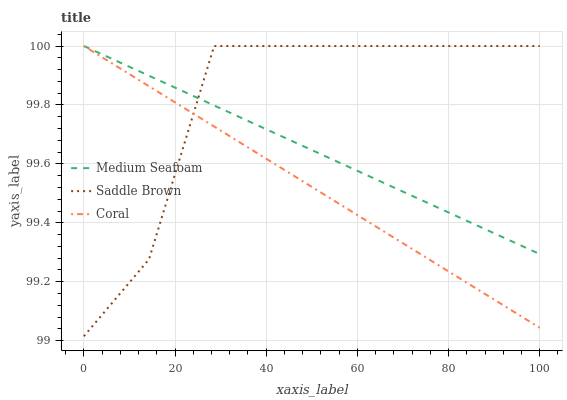Does Coral have the minimum area under the curve?
Answer yes or no. Yes. Does Saddle Brown have the maximum area under the curve?
Answer yes or no. Yes. Does Medium Seafoam have the minimum area under the curve?
Answer yes or no. No. Does Medium Seafoam have the maximum area under the curve?
Answer yes or no. No. Is Coral the smoothest?
Answer yes or no. Yes. Is Saddle Brown the roughest?
Answer yes or no. Yes. Is Medium Seafoam the smoothest?
Answer yes or no. No. Is Medium Seafoam the roughest?
Answer yes or no. No. Does Saddle Brown have the lowest value?
Answer yes or no. Yes. Does Medium Seafoam have the lowest value?
Answer yes or no. No. Does Saddle Brown have the highest value?
Answer yes or no. Yes. Does Medium Seafoam intersect Coral?
Answer yes or no. Yes. Is Medium Seafoam less than Coral?
Answer yes or no. No. Is Medium Seafoam greater than Coral?
Answer yes or no. No. 